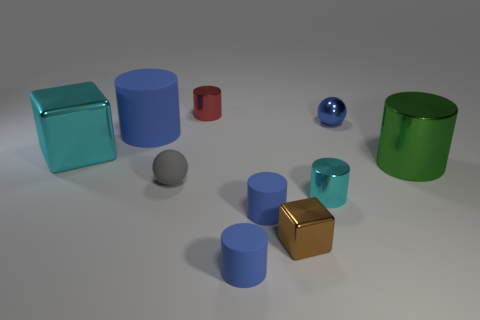How many blue cylinders must be subtracted to get 1 blue cylinders? 2 Subtract all red spheres. How many blue cylinders are left? 3 Subtract all tiny red shiny cylinders. How many cylinders are left? 5 Subtract all cyan cylinders. How many cylinders are left? 5 Subtract all purple cylinders. Subtract all red blocks. How many cylinders are left? 6 Subtract all balls. How many objects are left? 8 Add 1 green objects. How many green objects are left? 2 Add 1 big purple cylinders. How many big purple cylinders exist? 1 Subtract 0 yellow cubes. How many objects are left? 10 Subtract all large rubber things. Subtract all tiny blue metallic things. How many objects are left? 8 